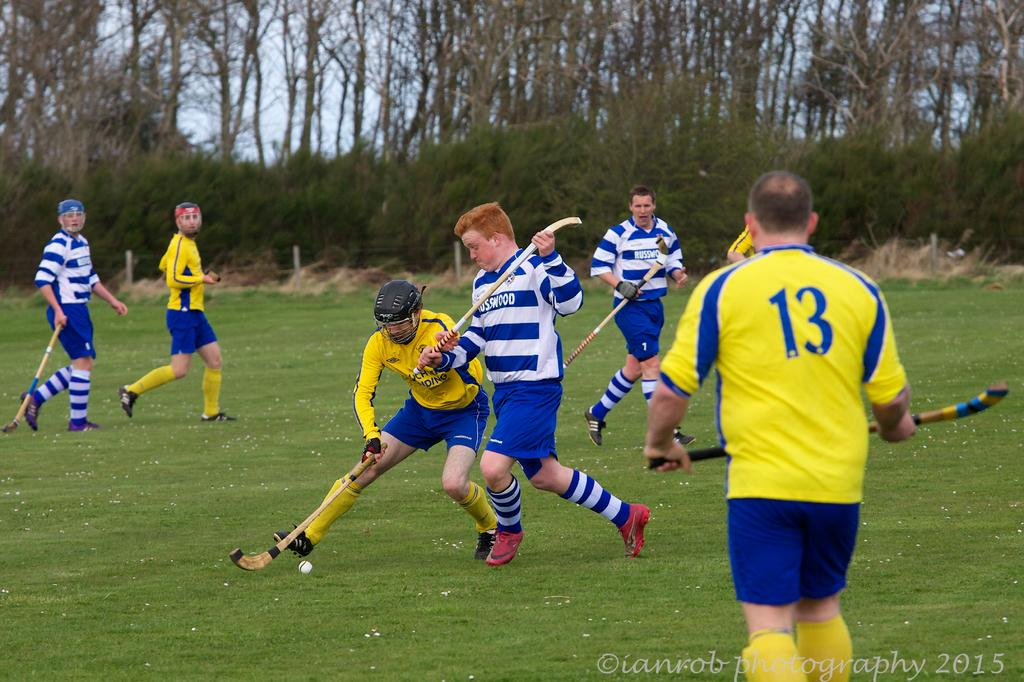Provide a one-sentence caption for the provided image. A group of field hockey players from Russwood play an opposing team. 